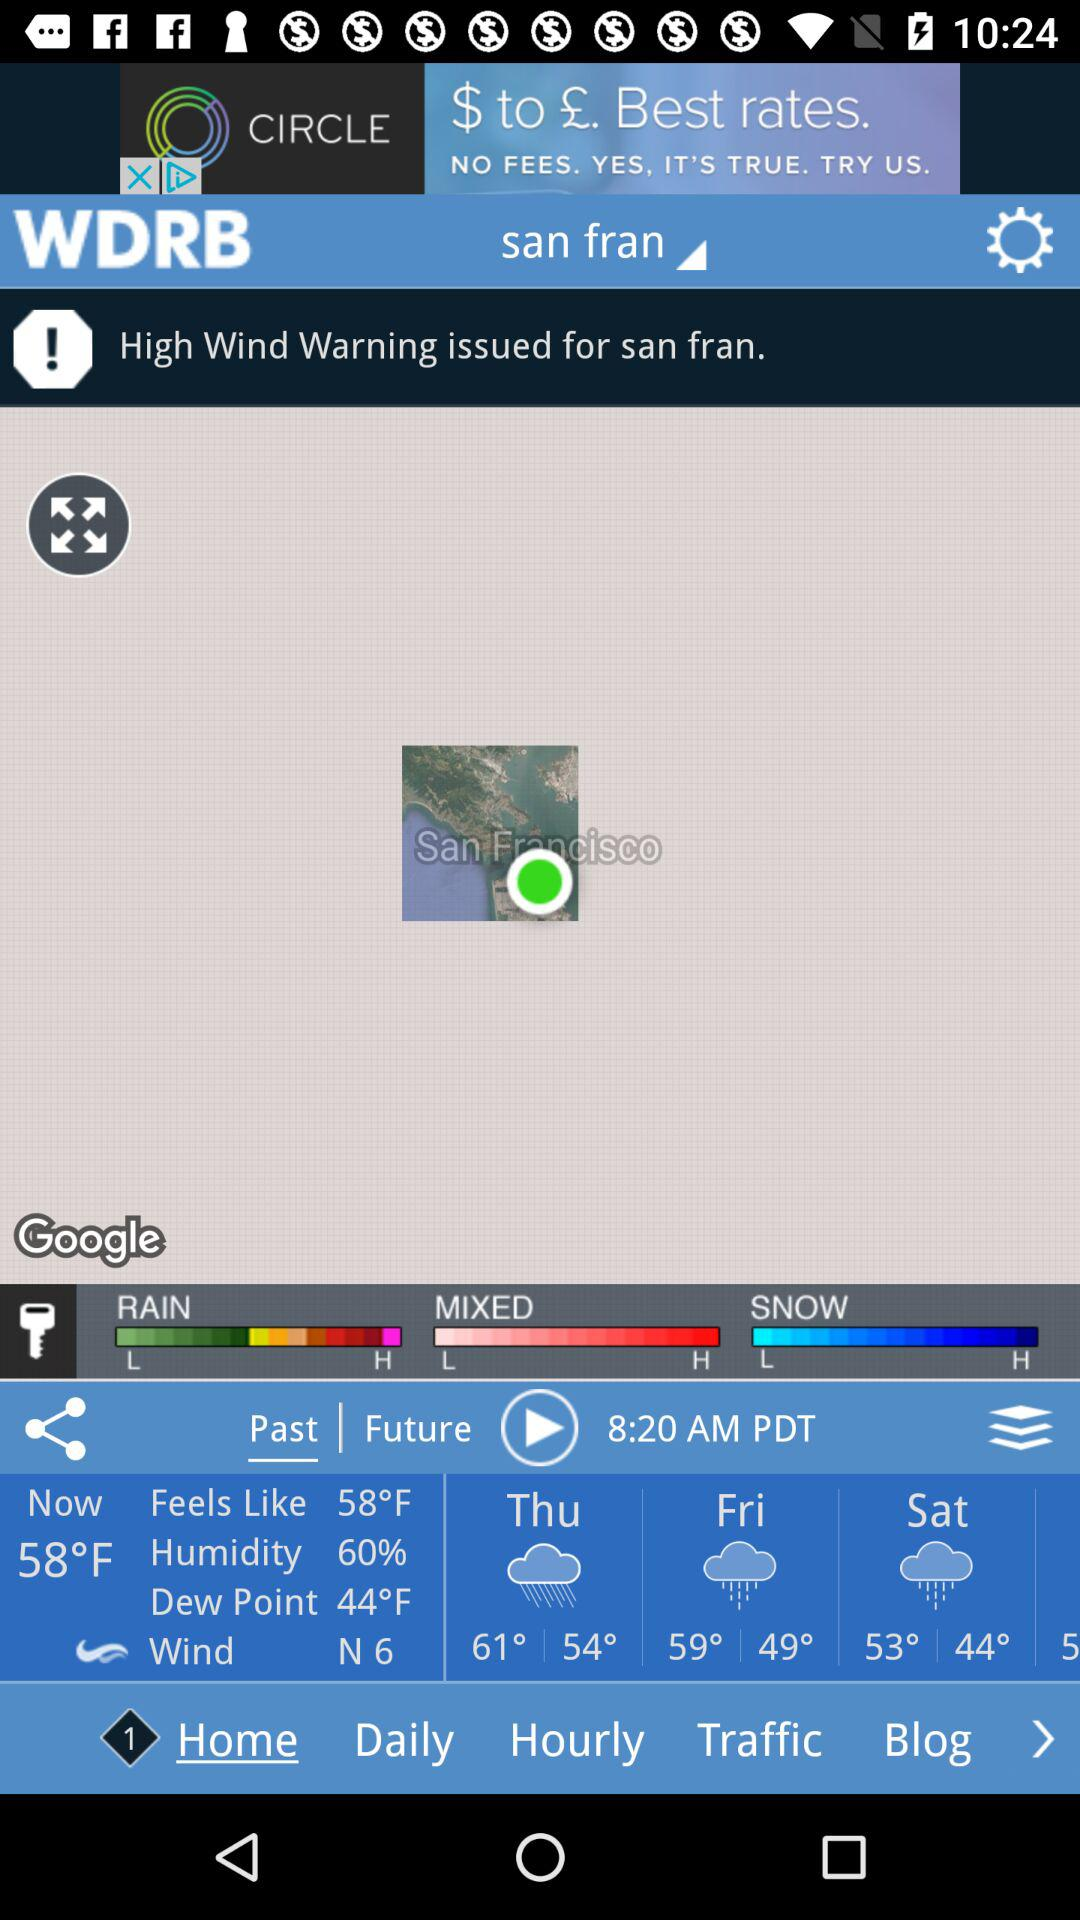How many days are there in the forecast?
Answer the question using a single word or phrase. 5 